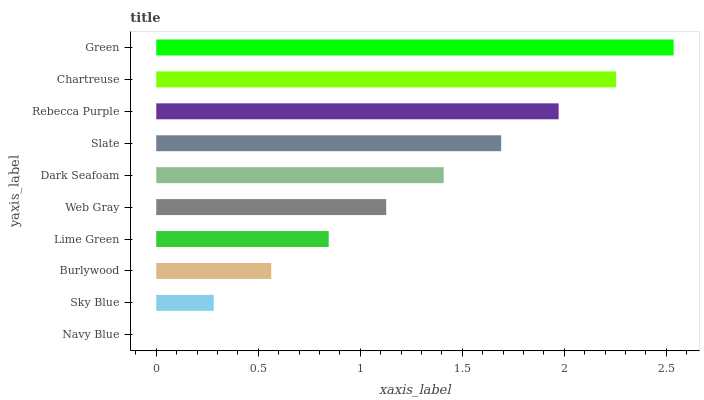Is Navy Blue the minimum?
Answer yes or no. Yes. Is Green the maximum?
Answer yes or no. Yes. Is Sky Blue the minimum?
Answer yes or no. No. Is Sky Blue the maximum?
Answer yes or no. No. Is Sky Blue greater than Navy Blue?
Answer yes or no. Yes. Is Navy Blue less than Sky Blue?
Answer yes or no. Yes. Is Navy Blue greater than Sky Blue?
Answer yes or no. No. Is Sky Blue less than Navy Blue?
Answer yes or no. No. Is Dark Seafoam the high median?
Answer yes or no. Yes. Is Web Gray the low median?
Answer yes or no. Yes. Is Web Gray the high median?
Answer yes or no. No. Is Navy Blue the low median?
Answer yes or no. No. 